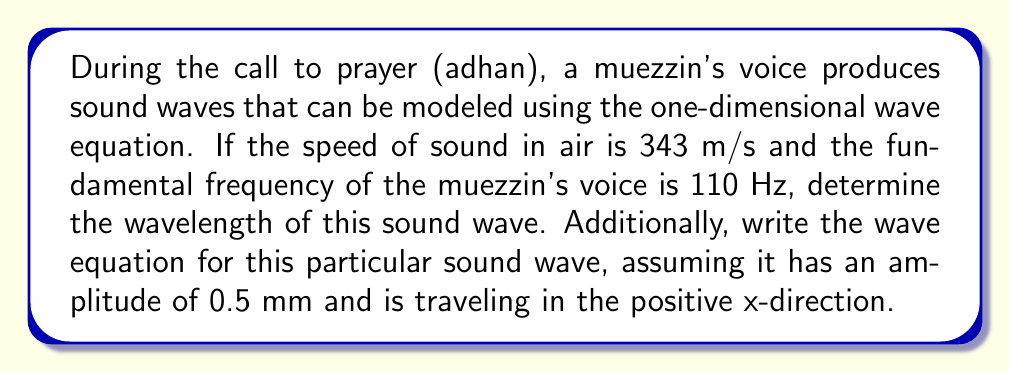Can you solve this math problem? Let's approach this problem step-by-step:

1. To find the wavelength, we use the wave equation:
   $$v = f\lambda$$
   where $v$ is the speed of sound, $f$ is the frequency, and $\lambda$ is the wavelength.

2. We're given:
   $v = 343$ m/s
   $f = 110$ Hz

3. Substituting these values:
   $$343 = 110\lambda$$

4. Solving for $\lambda$:
   $$\lambda = \frac{343}{110} = 3.118$$ meters

5. Now, for the wave equation, we use the general form:
   $$y(x,t) = A \sin(kx - \omega t)$$
   where $A$ is the amplitude, $k$ is the wave number, and $\omega$ is the angular frequency.

6. We're given $A = 0.5$ mm = $0.0005$ m

7. The wave number $k$ is calculated as:
   $$k = \frac{2\pi}{\lambda} = \frac{2\pi}{3.118} = 2.015$$ rad/m

8. The angular frequency $\omega$ is:
   $$\omega = 2\pi f = 2\pi(110) = 691.15$$ rad/s

9. Substituting these values into the wave equation:
   $$y(x,t) = 0.0005 \sin(2.015x - 691.15t)$$

This equation represents the propagation of the sound wave during the call to prayer.
Answer: $\lambda = 3.118$ m; $y(x,t) = 0.0005 \sin(2.015x - 691.15t)$ 